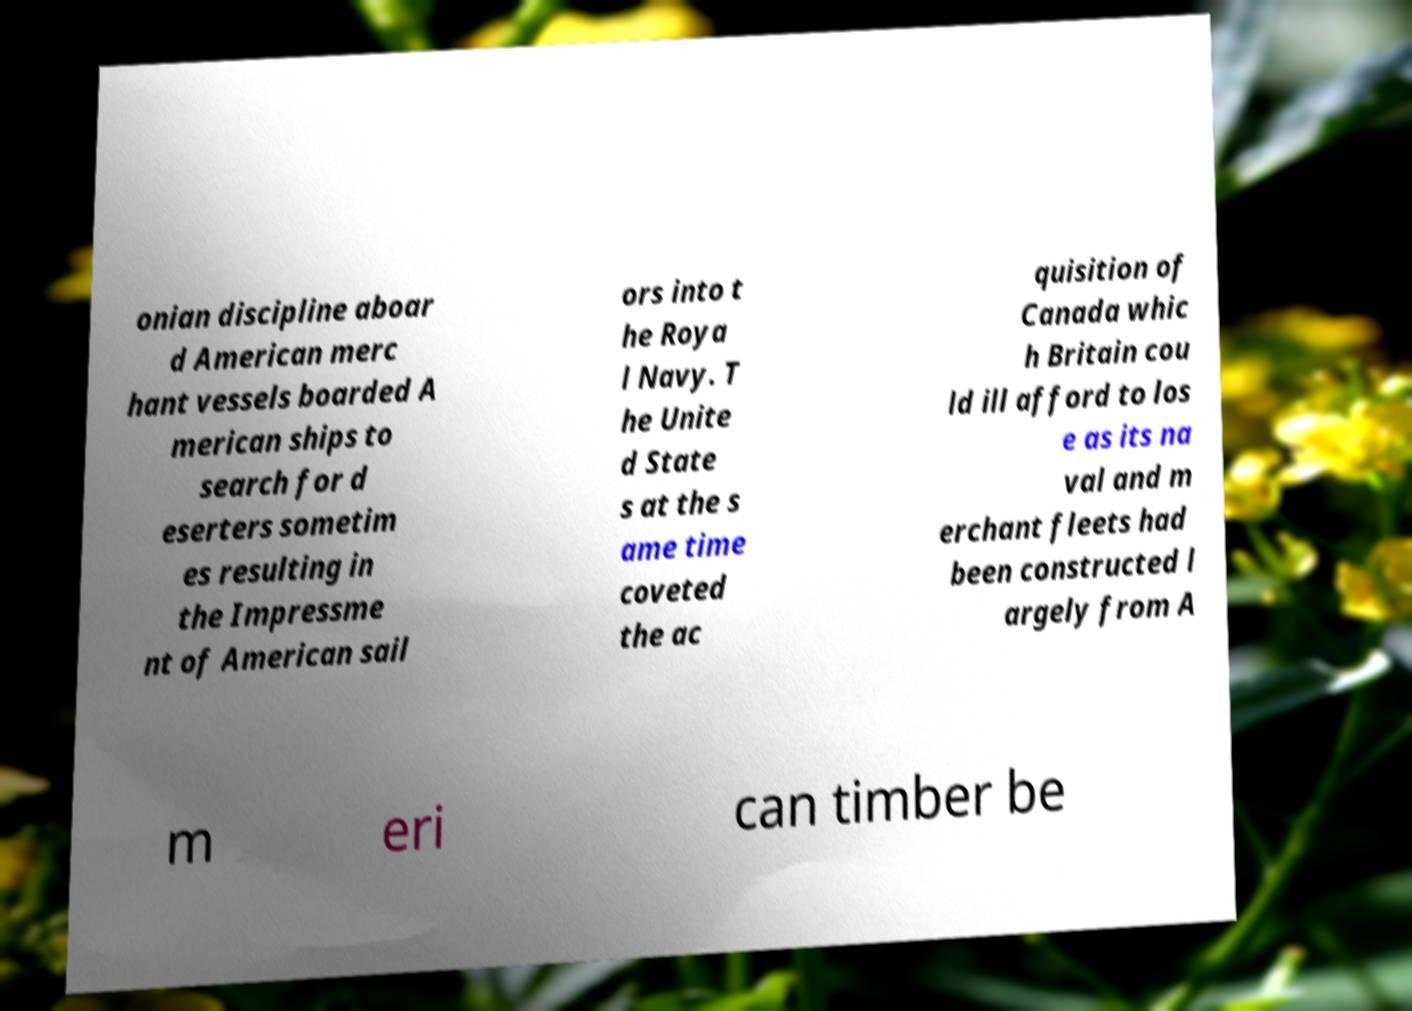I need the written content from this picture converted into text. Can you do that? onian discipline aboar d American merc hant vessels boarded A merican ships to search for d eserters sometim es resulting in the Impressme nt of American sail ors into t he Roya l Navy. T he Unite d State s at the s ame time coveted the ac quisition of Canada whic h Britain cou ld ill afford to los e as its na val and m erchant fleets had been constructed l argely from A m eri can timber be 